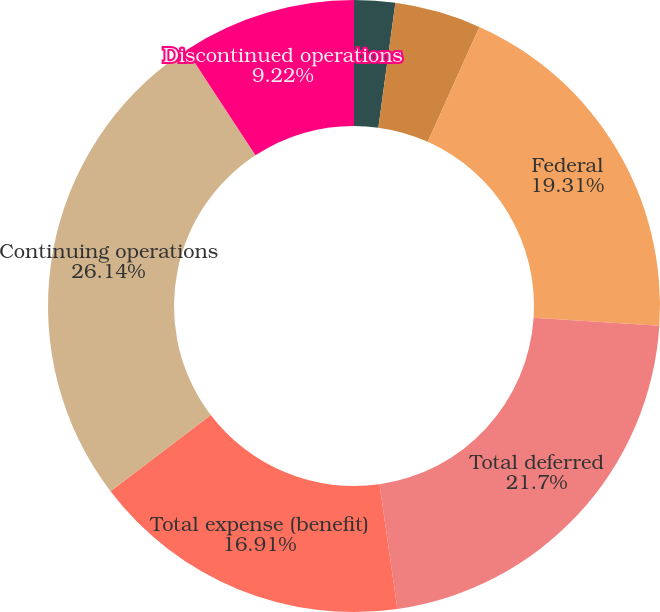<chart> <loc_0><loc_0><loc_500><loc_500><pie_chart><fcel>State<fcel>Total current<fcel>Federal<fcel>Total deferred<fcel>Total expense (benefit)<fcel>Continuing operations<fcel>Discontinued operations<nl><fcel>2.16%<fcel>4.56%<fcel>19.31%<fcel>21.7%<fcel>16.91%<fcel>26.13%<fcel>9.22%<nl></chart> 